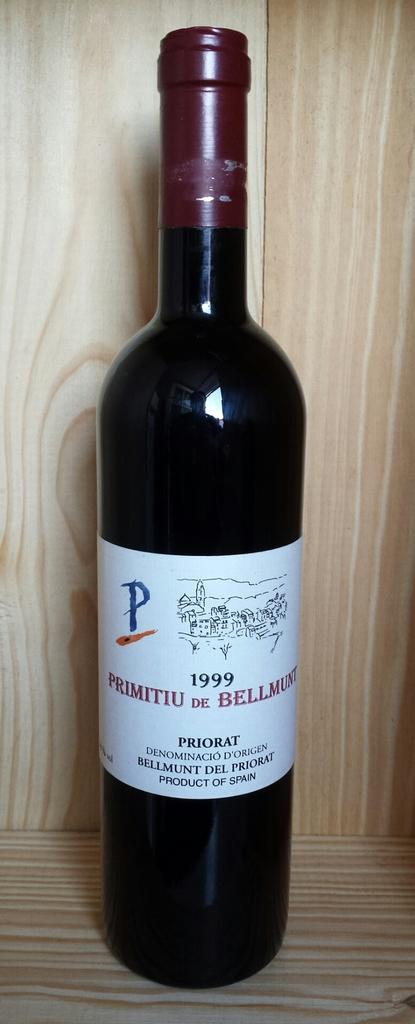<image>
Give a short and clear explanation of the subsequent image. a bottle that has the year of 1999 on it 